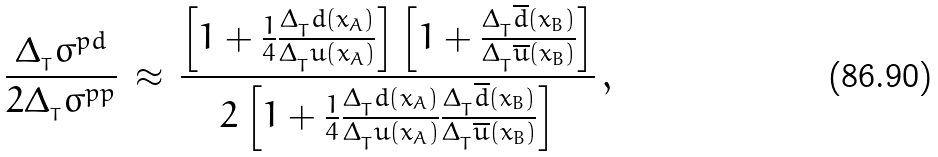<formula> <loc_0><loc_0><loc_500><loc_500>\frac { \Delta _ { _ { T } } \sigma ^ { p d } } { 2 \Delta _ { _ { T } } \sigma ^ { p p } } \, \approx \, \frac { \left [ 1 + \frac { 1 } { 4 } \frac { \Delta _ { _ { T } } d \left ( x _ { A } \right ) } { \Delta _ { _ { T } } u \left ( x _ { A } \right ) } \right ] \left [ 1 + \frac { \Delta _ { _ { T } } \overline { d } \left ( x _ { B } \right ) } { \Delta _ { _ { T } } \overline { u } \left ( x _ { B } \right ) } \right ] } { 2 \left [ 1 + \frac { 1 } { 4 } \frac { \Delta _ { _ { T } } d \left ( x _ { A } \right ) } { \Delta _ { _ { T } } u \left ( x _ { A } \right ) } \frac { \Delta _ { _ { T } } \overline { d } \left ( x _ { B } \right ) } { \Delta _ { _ { T } } \overline { u } \left ( x _ { B } \right ) } \right ] } \, ,</formula> 